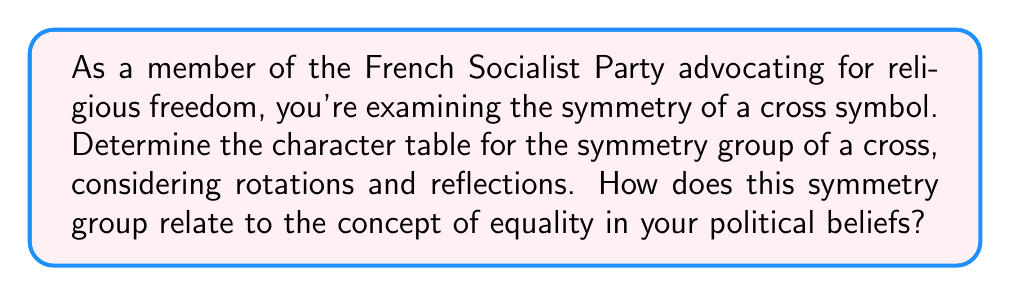What is the answer to this math problem? Let's approach this step-by-step:

1) First, identify the symmetries of a cross:
   - Identity (E)
   - Rotation by 180° (C2)
   - Reflection across vertical axis (σv)
   - Reflection across horizontal axis (σh)

2) This forms a group of order 4, which is isomorphic to the Klein four-group V4.

3) The conjugacy classes are:
   {E}, {C2}, {σv}, {σh}

4) There are 4 irreducible representations, all 1-dimensional.

5) Character table construction:
   - χ1: trivial representation (all 1's)
   - χ2: C2 = 1, σv = σh = -1
   - χ3: σv = 1, C2 = σh = -1
   - χ4: σh = 1, C2 = σv = -1

6) The character table:

   $$\begin{array}{c|cccc}
      V_4 & E & C_2 & \sigma_v & \sigma_h \\
      \hline
      \chi_1 & 1 & 1 & 1 & 1 \\
      \chi_2 & 1 & 1 & -1 & -1 \\
      \chi_3 & 1 & -1 & 1 & -1 \\
      \chi_4 & 1 & -1 & -1 & 1
   \end{array}$$

7) Political interpretation: The symmetry group of the cross, with its equal treatment of vertical and horizontal reflections, can be seen as a metaphor for equality and balance in socialist ideals. Each symmetry operation (representation) has equal importance, reflecting the party's commitment to equal rights and opportunities for all citizens, regardless of their religious beliefs.
Answer: $$\begin{array}{c|cccc}
   V_4 & E & C_2 & \sigma_v & \sigma_h \\
   \hline
   \chi_1 & 1 & 1 & 1 & 1 \\
   \chi_2 & 1 & 1 & -1 & -1 \\
   \chi_3 & 1 & -1 & 1 & -1 \\
   \chi_4 & 1 & -1 & -1 & 1
\end{array}$$ 